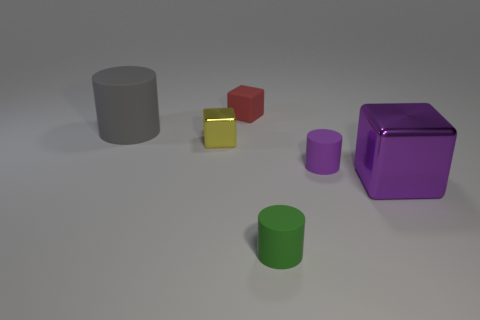Are there any other things that are the same color as the tiny shiny thing?
Your answer should be very brief. No. What color is the tiny thing that is in front of the big gray matte cylinder and behind the small purple rubber thing?
Give a very brief answer. Yellow. There is a matte thing that is left of the red cube; is its size the same as the large purple block?
Your answer should be compact. Yes. Are there more yellow metallic blocks to the left of the tiny yellow cube than purple rubber objects?
Give a very brief answer. No. Is the shape of the gray thing the same as the small yellow object?
Ensure brevity in your answer.  No. What is the size of the purple matte thing?
Ensure brevity in your answer.  Small. Are there more things that are behind the small red cube than small yellow metal cubes that are behind the small metal object?
Make the answer very short. No. Are there any small red objects right of the green rubber object?
Keep it short and to the point. No. Are there any gray shiny objects that have the same size as the green matte cylinder?
Ensure brevity in your answer.  No. The big cylinder that is made of the same material as the tiny red cube is what color?
Your response must be concise. Gray. 